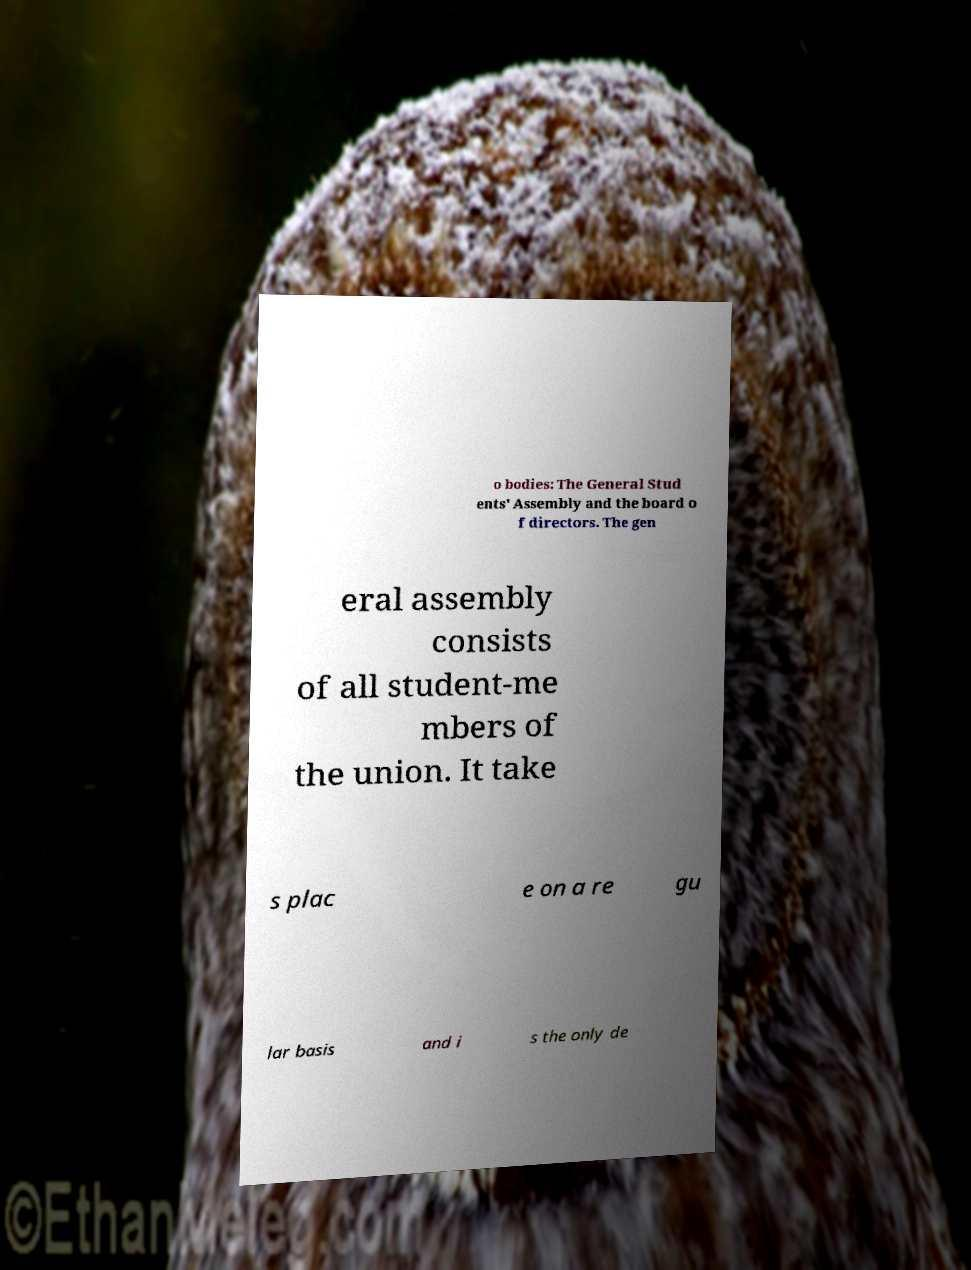Please read and relay the text visible in this image. What does it say? o bodies: The General Stud ents' Assembly and the board o f directors. The gen eral assembly consists of all student-me mbers of the union. It take s plac e on a re gu lar basis and i s the only de 